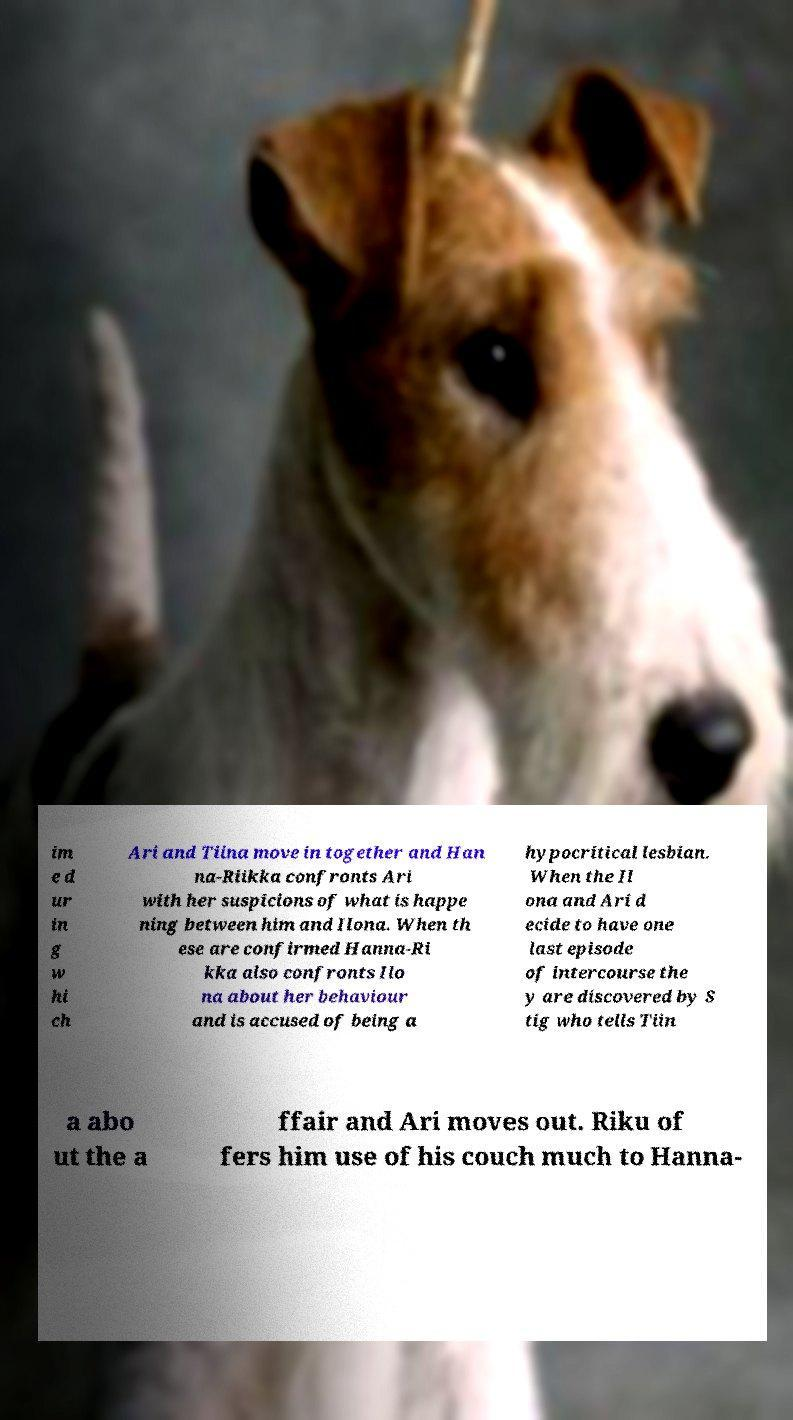Please identify and transcribe the text found in this image. im e d ur in g w hi ch Ari and Tiina move in together and Han na-Riikka confronts Ari with her suspicions of what is happe ning between him and Ilona. When th ese are confirmed Hanna-Ri kka also confronts Ilo na about her behaviour and is accused of being a hypocritical lesbian. When the Il ona and Ari d ecide to have one last episode of intercourse the y are discovered by S tig who tells Tiin a abo ut the a ffair and Ari moves out. Riku of fers him use of his couch much to Hanna- 